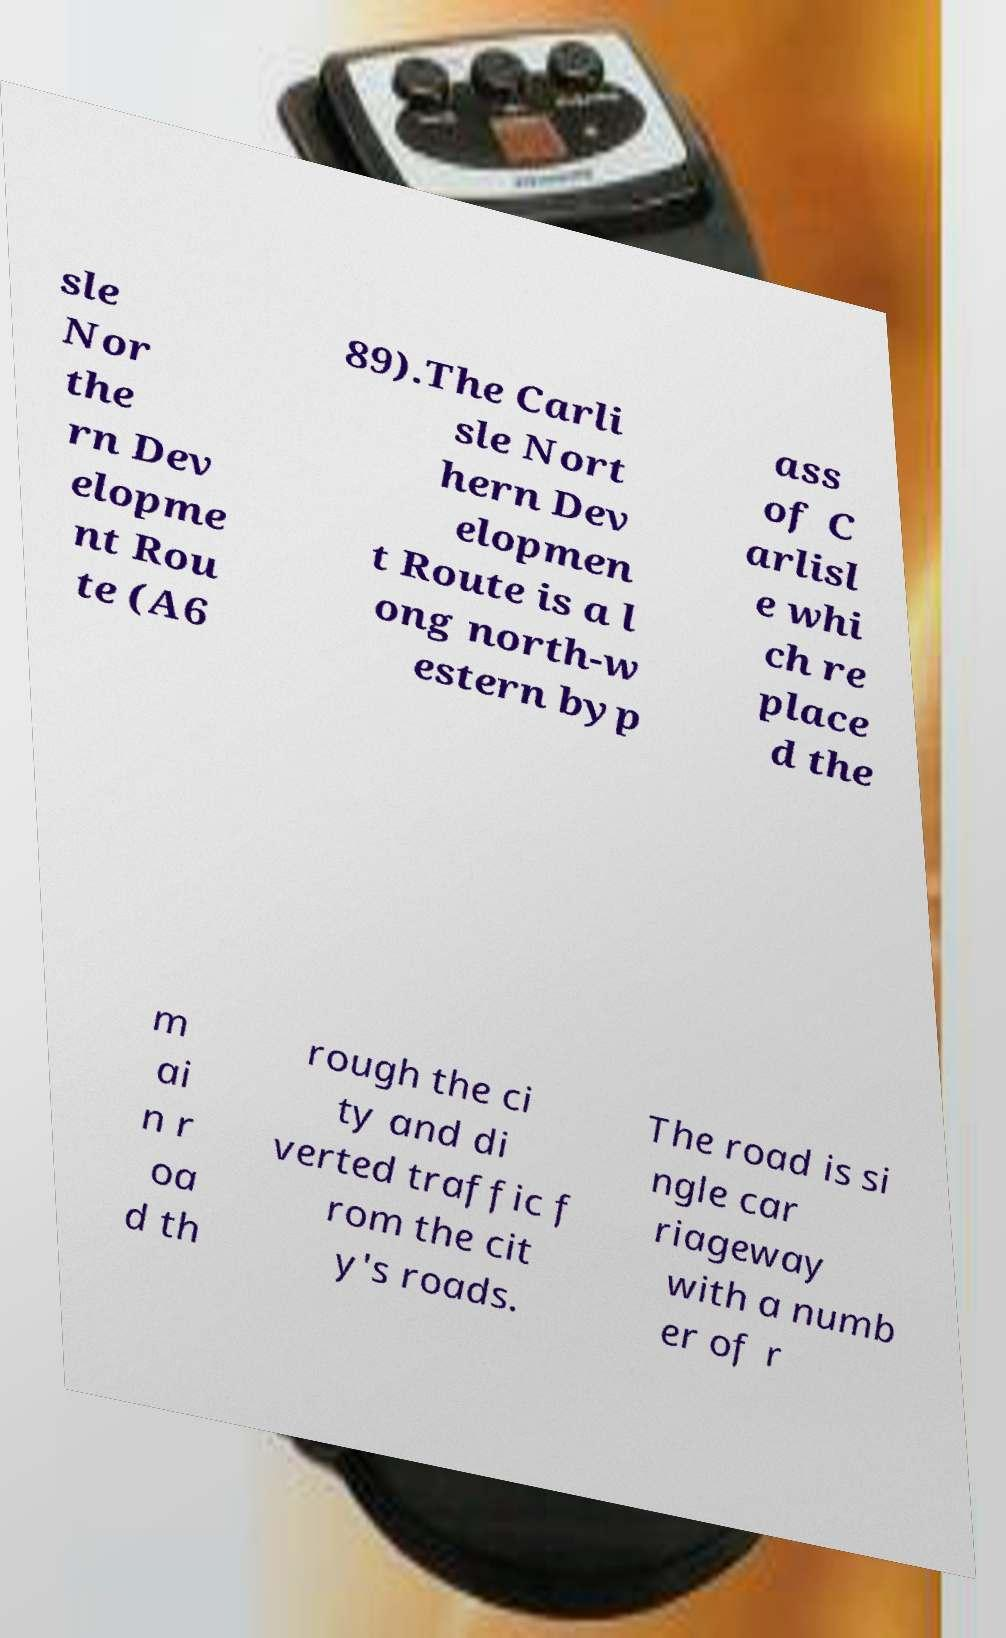Can you read and provide the text displayed in the image?This photo seems to have some interesting text. Can you extract and type it out for me? sle Nor the rn Dev elopme nt Rou te (A6 89).The Carli sle Nort hern Dev elopmen t Route is a l ong north-w estern byp ass of C arlisl e whi ch re place d the m ai n r oa d th rough the ci ty and di verted traffic f rom the cit y's roads. The road is si ngle car riageway with a numb er of r 